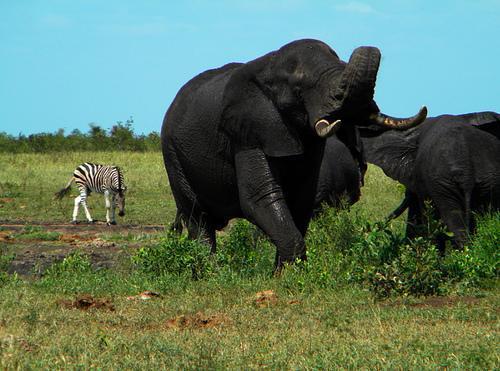How many animals are in the photo?
Give a very brief answer. 4. How many elephants are in the photo?
Give a very brief answer. 3. 